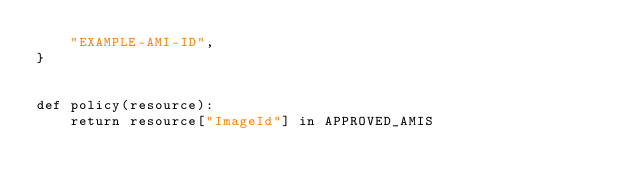<code> <loc_0><loc_0><loc_500><loc_500><_Python_>    "EXAMPLE-AMI-ID",
}


def policy(resource):
    return resource["ImageId"] in APPROVED_AMIS
</code> 